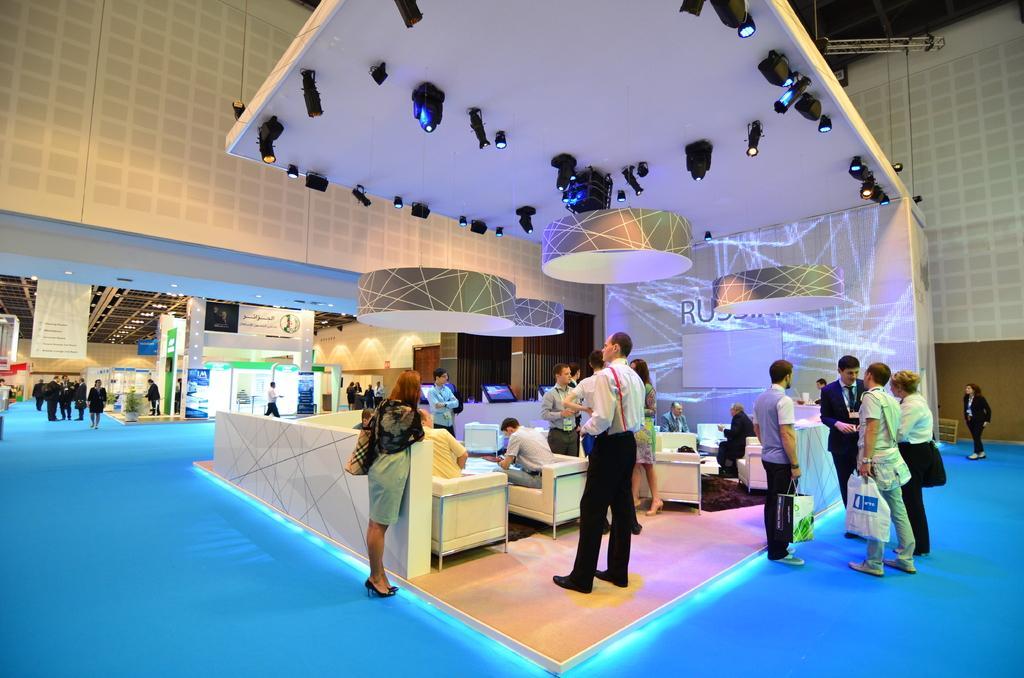Please provide a concise description of this image. In this image we can see people sitting on the sofa and some are standing on the floor. In the background we can see electric lights, information boards and advertisements hanged to the wall. 